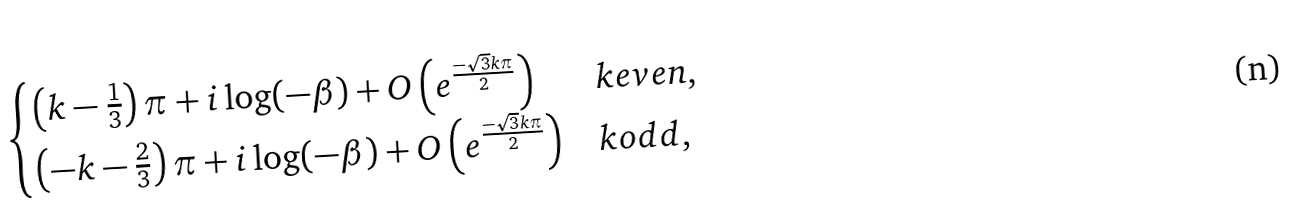Convert formula to latex. <formula><loc_0><loc_0><loc_500><loc_500>\begin{cases} \left ( k - \frac { 1 } { 3 } \right ) \pi + i \log ( - \beta ) + O \left ( e ^ { \frac { - \sqrt { 3 } k \pi } { 2 } } \right ) & k e v e n , \\ \left ( - k - \frac { 2 } { 3 } \right ) \pi + i \log ( - \beta ) + O \left ( e ^ { \frac { - \sqrt { 3 } k \pi } { 2 } } \right ) & k o d d , \end{cases}</formula> 